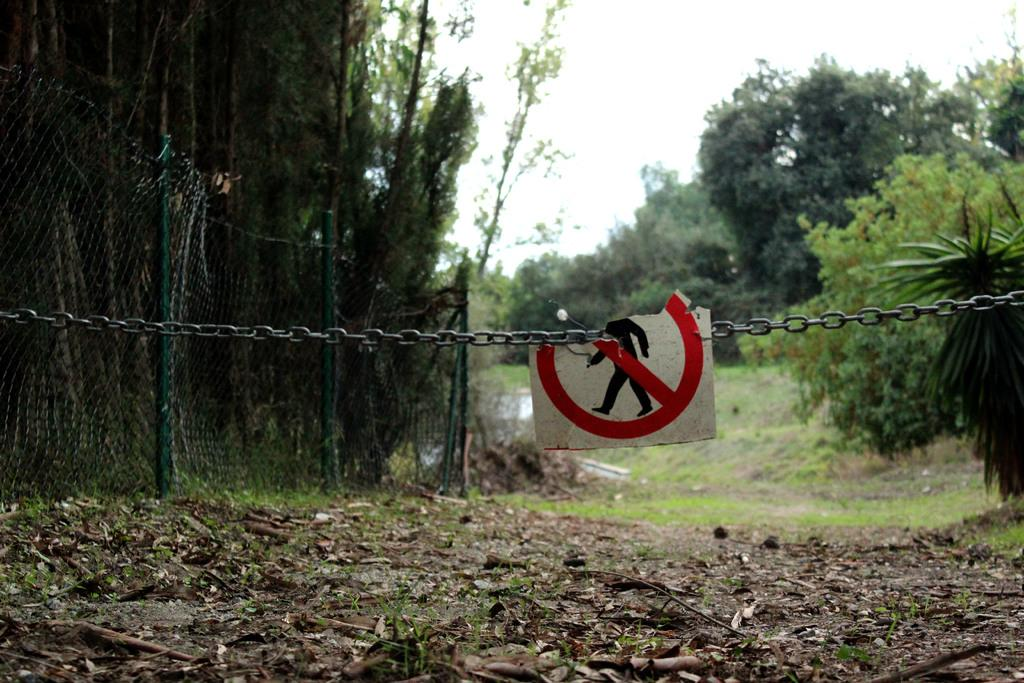What is attached to a chain in the image? There is a board attached to a chain in the image. What can be seen on the left side of the image? There is a fence on the left side of the image. What type of vegetation is visible in the image? There are many trees visible in the image. What is the color of the sky in the background of the image? The sky is white in the background of the image. What type of watch can be seen on the tree in the image? There is no watch present in the image; it features a board attached to a chain, a fence, trees, and a white sky. 